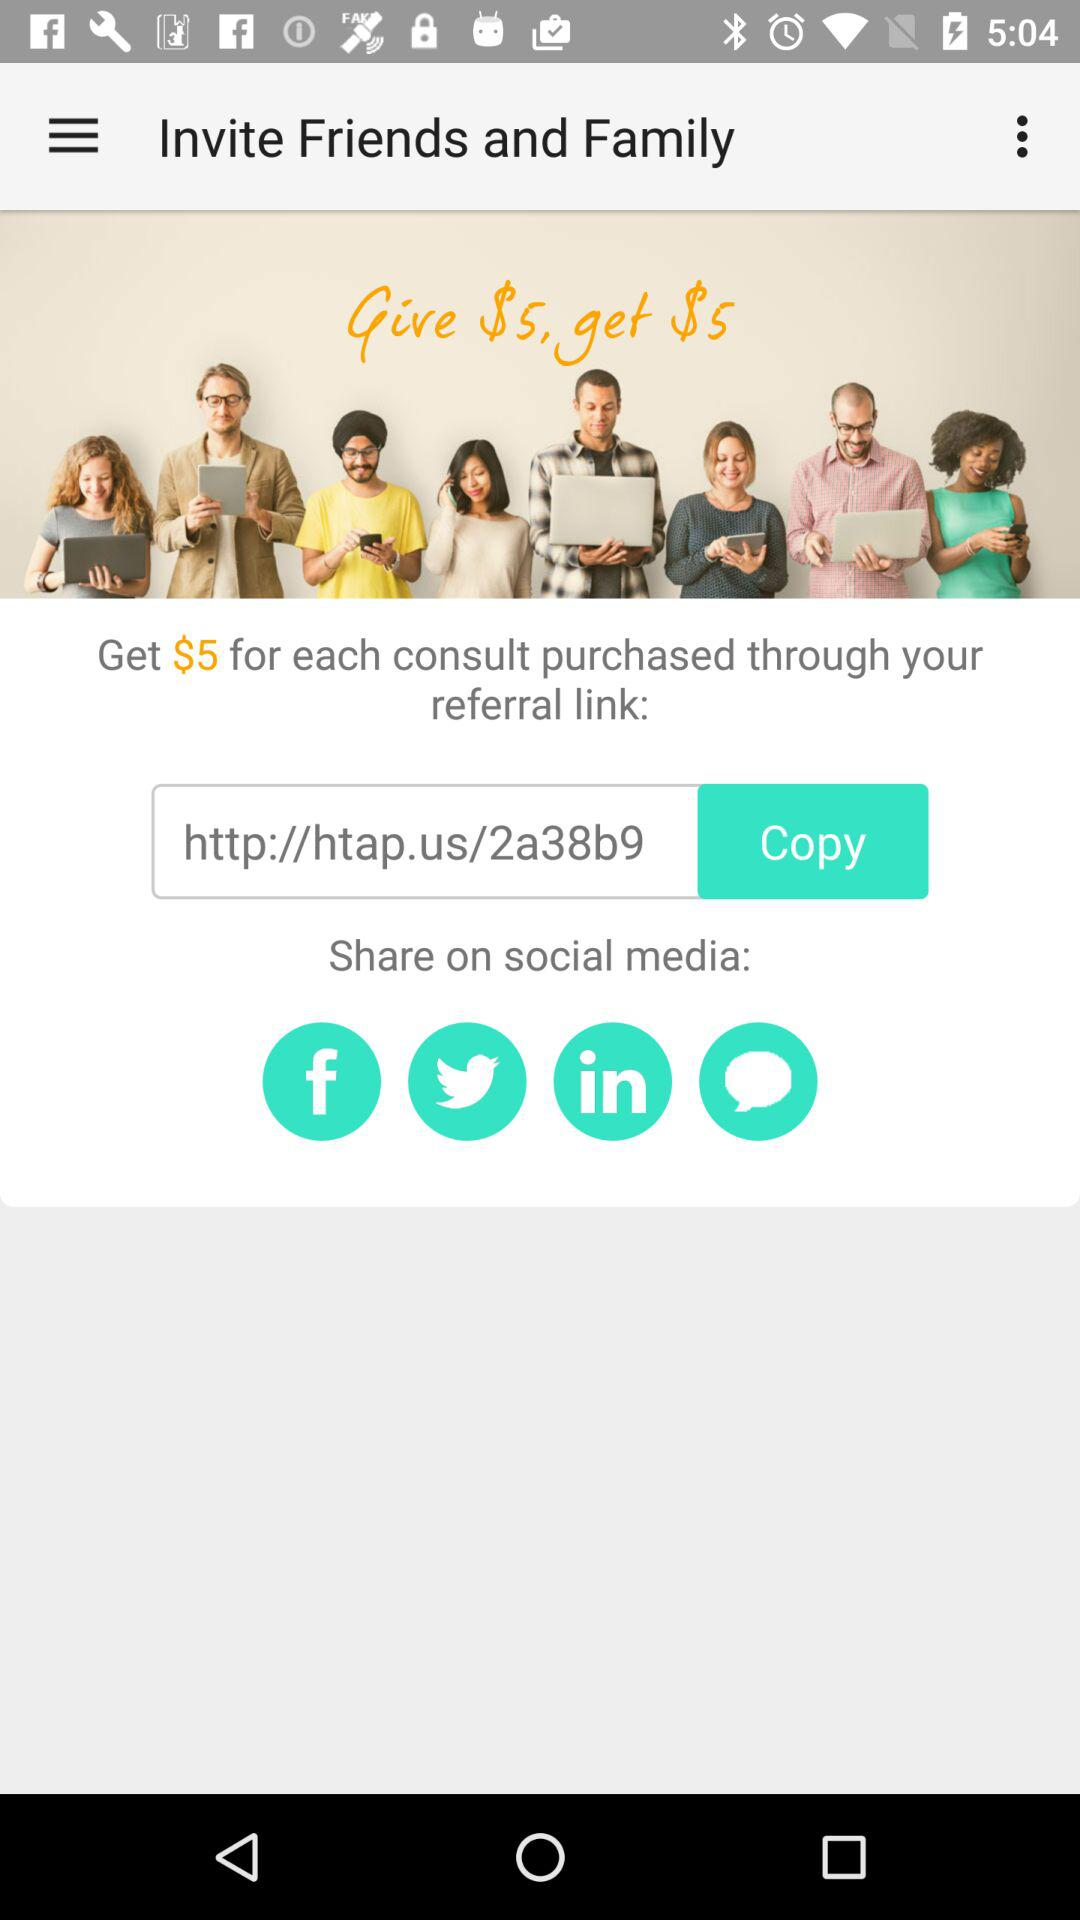How much do I get for each consult purchased through my referral link?
Answer the question using a single word or phrase. $5 